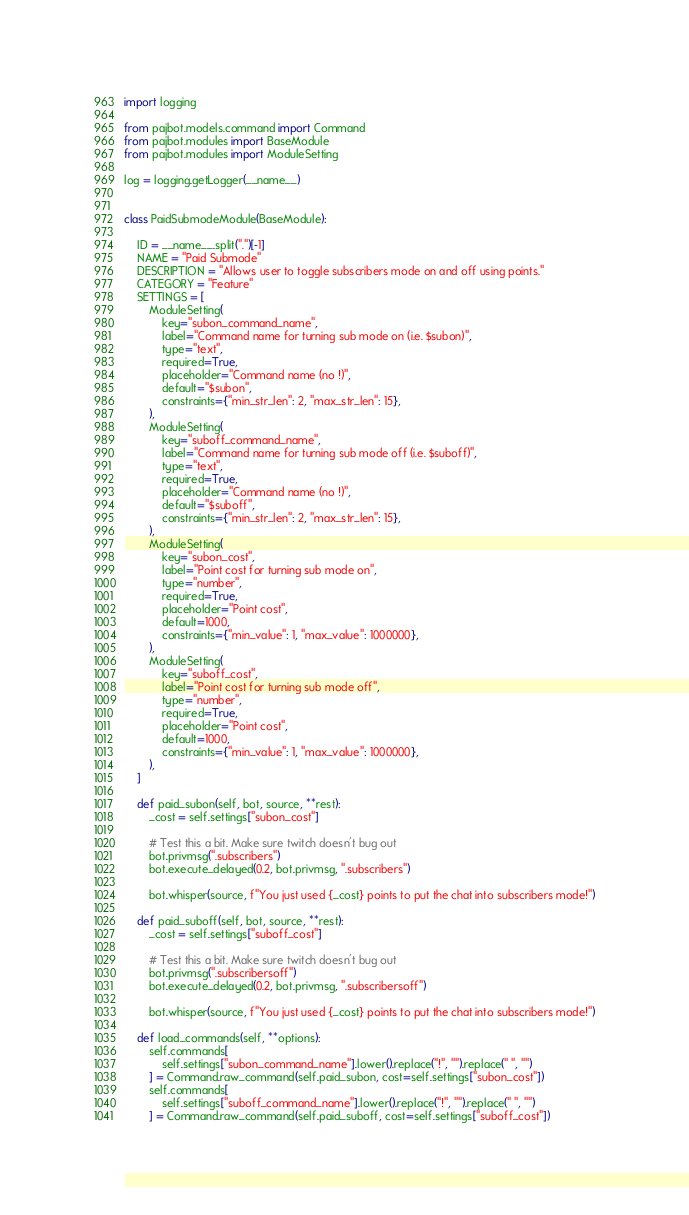Convert code to text. <code><loc_0><loc_0><loc_500><loc_500><_Python_>import logging

from pajbot.models.command import Command
from pajbot.modules import BaseModule
from pajbot.modules import ModuleSetting

log = logging.getLogger(__name__)


class PaidSubmodeModule(BaseModule):

    ID = __name__.split(".")[-1]
    NAME = "Paid Submode"
    DESCRIPTION = "Allows user to toggle subscribers mode on and off using points."
    CATEGORY = "Feature"
    SETTINGS = [
        ModuleSetting(
            key="subon_command_name",
            label="Command name for turning sub mode on (i.e. $subon)",
            type="text",
            required=True,
            placeholder="Command name (no !)",
            default="$subon",
            constraints={"min_str_len": 2, "max_str_len": 15},
        ),
        ModuleSetting(
            key="suboff_command_name",
            label="Command name for turning sub mode off (i.e. $suboff)",
            type="text",
            required=True,
            placeholder="Command name (no !)",
            default="$suboff",
            constraints={"min_str_len": 2, "max_str_len": 15},
        ),
        ModuleSetting(
            key="subon_cost",
            label="Point cost for turning sub mode on",
            type="number",
            required=True,
            placeholder="Point cost",
            default=1000,
            constraints={"min_value": 1, "max_value": 1000000},
        ),
        ModuleSetting(
            key="suboff_cost",
            label="Point cost for turning sub mode off",
            type="number",
            required=True,
            placeholder="Point cost",
            default=1000,
            constraints={"min_value": 1, "max_value": 1000000},
        ),
    ]

    def paid_subon(self, bot, source, **rest):
        _cost = self.settings["subon_cost"]

        # Test this a bit. Make sure twitch doesn't bug out
        bot.privmsg(".subscribers")
        bot.execute_delayed(0.2, bot.privmsg, ".subscribers")

        bot.whisper(source, f"You just used {_cost} points to put the chat into subscribers mode!")

    def paid_suboff(self, bot, source, **rest):
        _cost = self.settings["suboff_cost"]

        # Test this a bit. Make sure twitch doesn't bug out
        bot.privmsg(".subscribersoff")
        bot.execute_delayed(0.2, bot.privmsg, ".subscribersoff")

        bot.whisper(source, f"You just used {_cost} points to put the chat into subscribers mode!")

    def load_commands(self, **options):
        self.commands[
            self.settings["subon_command_name"].lower().replace("!", "").replace(" ", "")
        ] = Command.raw_command(self.paid_subon, cost=self.settings["subon_cost"])
        self.commands[
            self.settings["suboff_command_name"].lower().replace("!", "").replace(" ", "")
        ] = Command.raw_command(self.paid_suboff, cost=self.settings["suboff_cost"])
</code> 